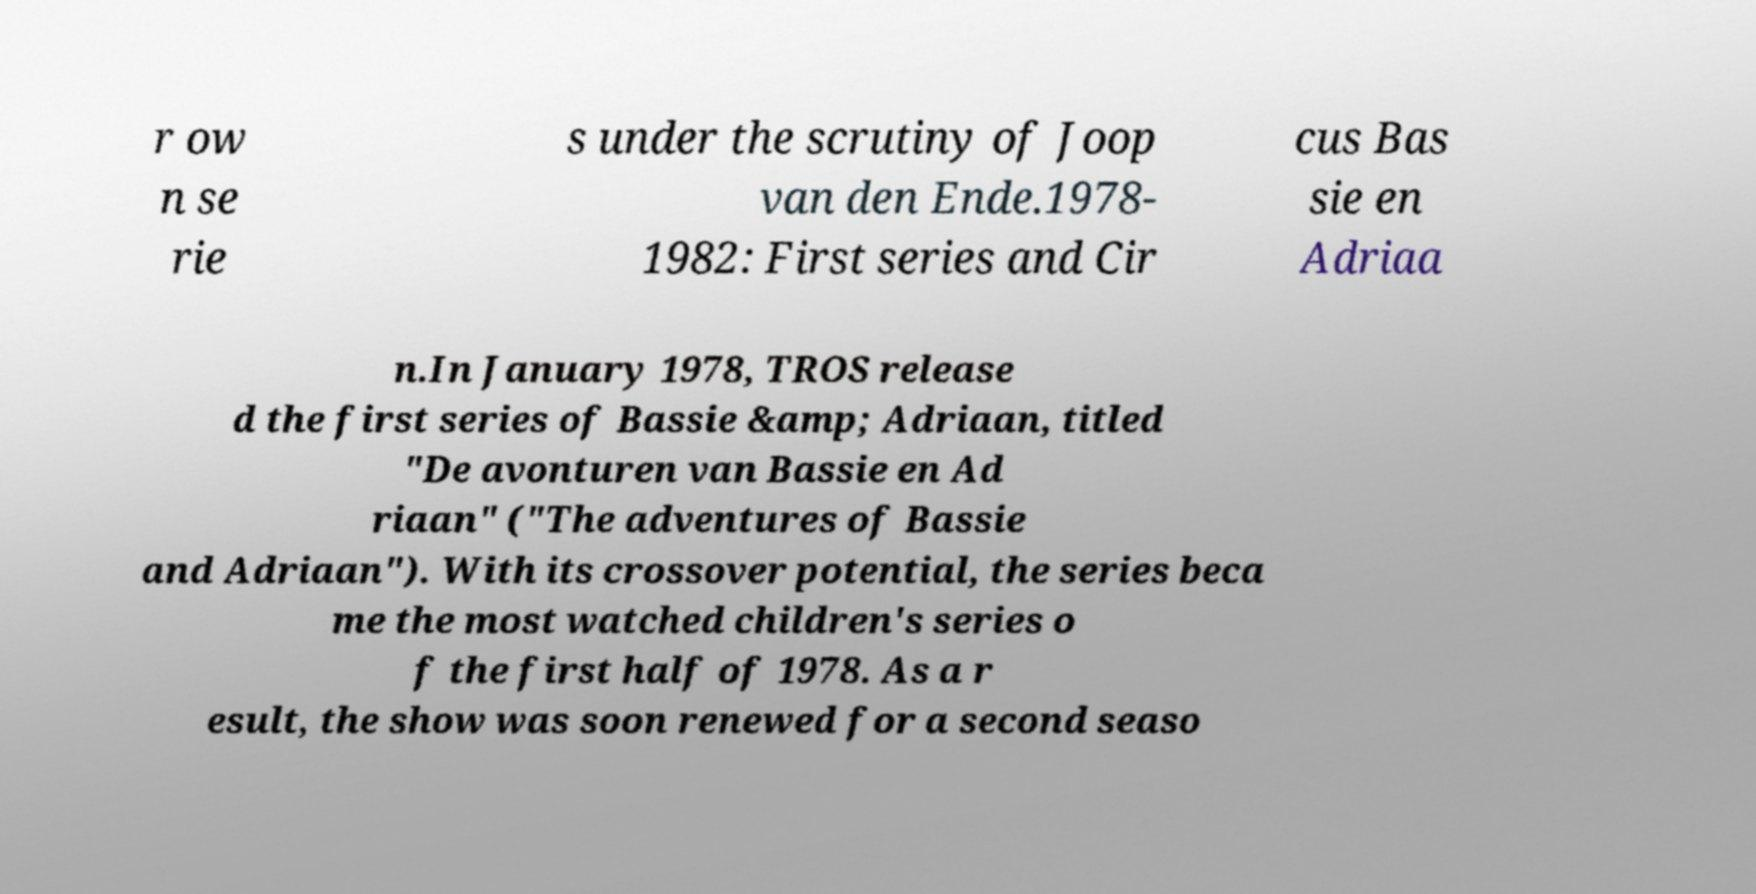Please identify and transcribe the text found in this image. r ow n se rie s under the scrutiny of Joop van den Ende.1978- 1982: First series and Cir cus Bas sie en Adriaa n.In January 1978, TROS release d the first series of Bassie &amp; Adriaan, titled "De avonturen van Bassie en Ad riaan" ("The adventures of Bassie and Adriaan"). With its crossover potential, the series beca me the most watched children's series o f the first half of 1978. As a r esult, the show was soon renewed for a second seaso 